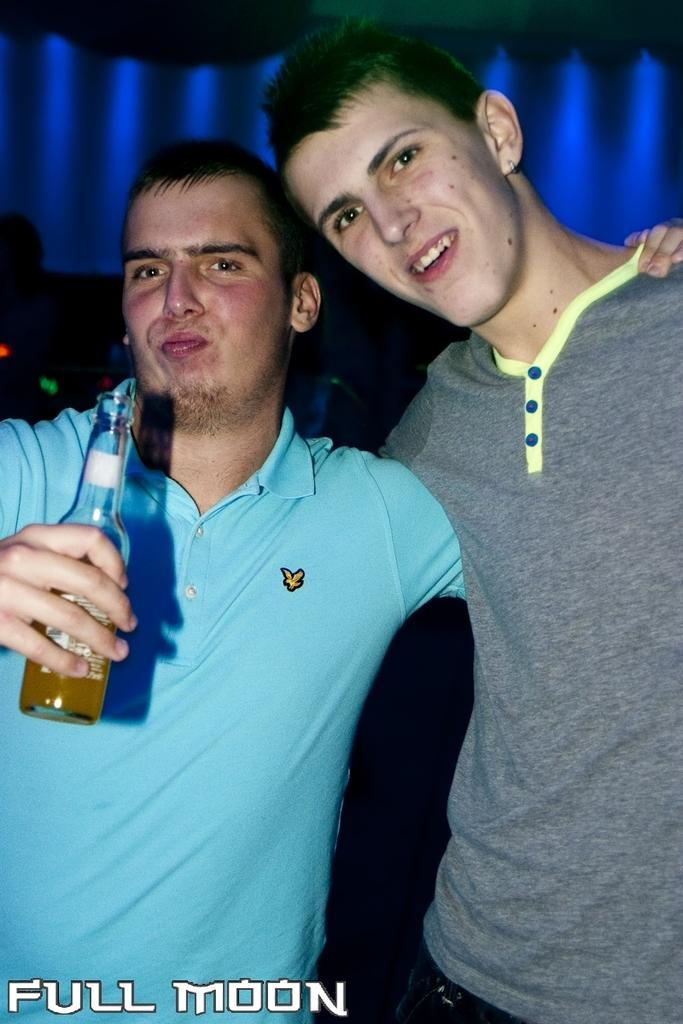How many people are present in the image? There are two men in the image. What is one of the men holding in his hand? One man is holding a bottle in his hand. What can be seen in the background of the image? There are blue color lights in the background of the image. What type of agreement did the two men reach in the image? There is no indication in the image of an agreement or any discussion between the two men in the image. 